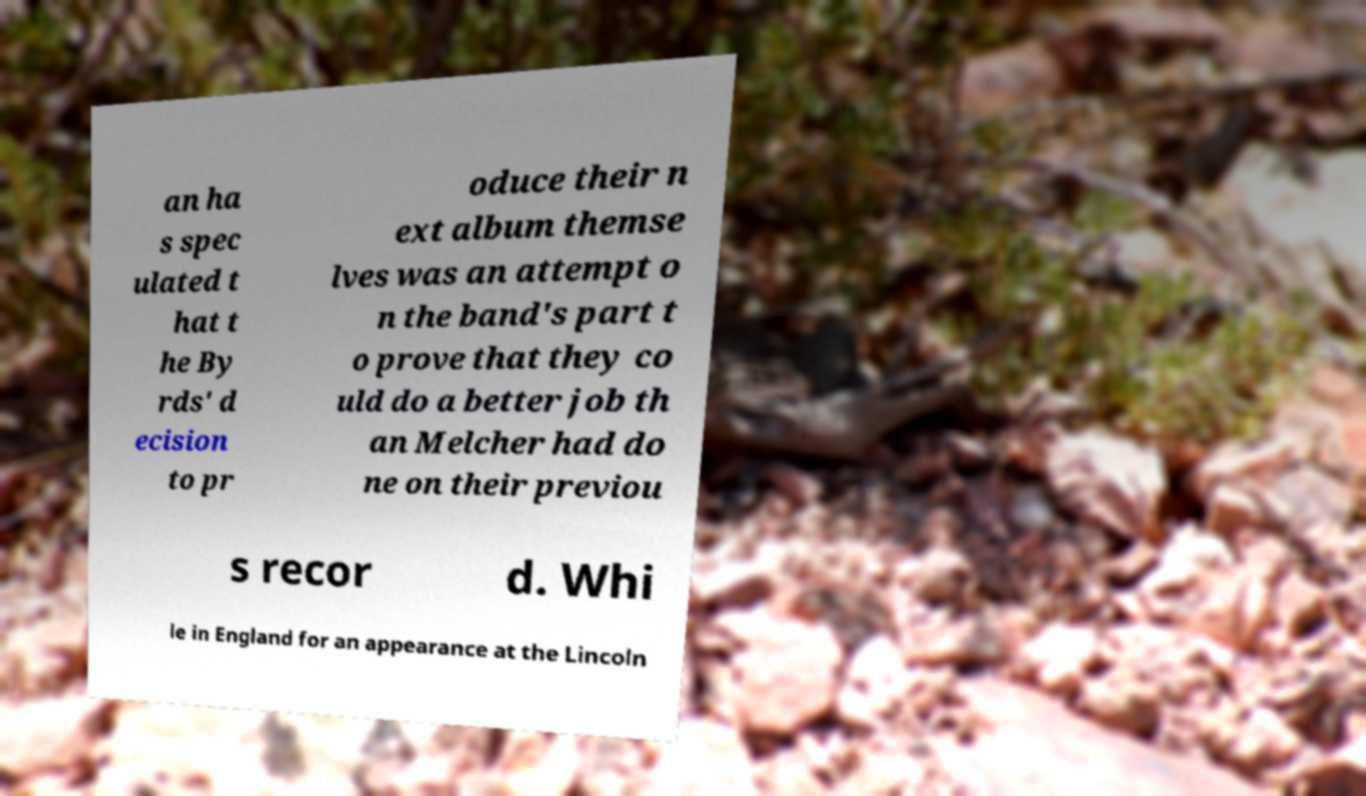Could you assist in decoding the text presented in this image and type it out clearly? an ha s spec ulated t hat t he By rds' d ecision to pr oduce their n ext album themse lves was an attempt o n the band's part t o prove that they co uld do a better job th an Melcher had do ne on their previou s recor d. Whi le in England for an appearance at the Lincoln 